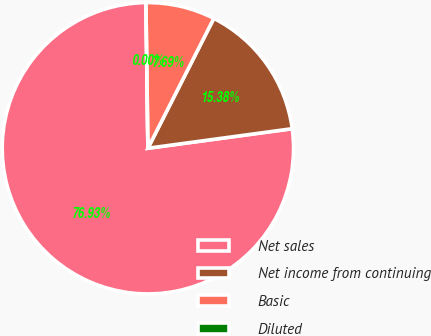Convert chart. <chart><loc_0><loc_0><loc_500><loc_500><pie_chart><fcel>Net sales<fcel>Net income from continuing<fcel>Basic<fcel>Diluted<nl><fcel>76.92%<fcel>15.38%<fcel>7.69%<fcel>0.0%<nl></chart> 